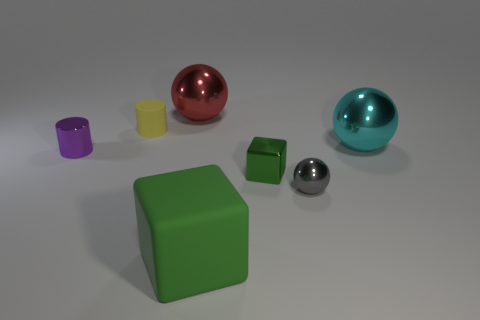What number of large red spheres are behind the large shiny thing that is behind the big cyan object?
Offer a very short reply. 0. There is a small purple object that is the same shape as the tiny yellow rubber object; what is its material?
Provide a succinct answer. Metal. There is a shiny sphere that is to the left of the small gray metallic sphere; is its color the same as the big rubber block?
Offer a terse response. No. Does the yellow cylinder have the same material as the small cylinder in front of the cyan object?
Offer a terse response. No. There is a green thing that is left of the tiny block; what shape is it?
Ensure brevity in your answer.  Cube. How many other things are there of the same material as the tiny green thing?
Ensure brevity in your answer.  4. What size is the rubber block?
Provide a short and direct response. Large. What number of other things are the same color as the small cube?
Give a very brief answer. 1. The object that is both in front of the tiny green shiny block and on the right side of the tiny cube is what color?
Make the answer very short. Gray. What number of small blue rubber objects are there?
Your answer should be very brief. 0. 